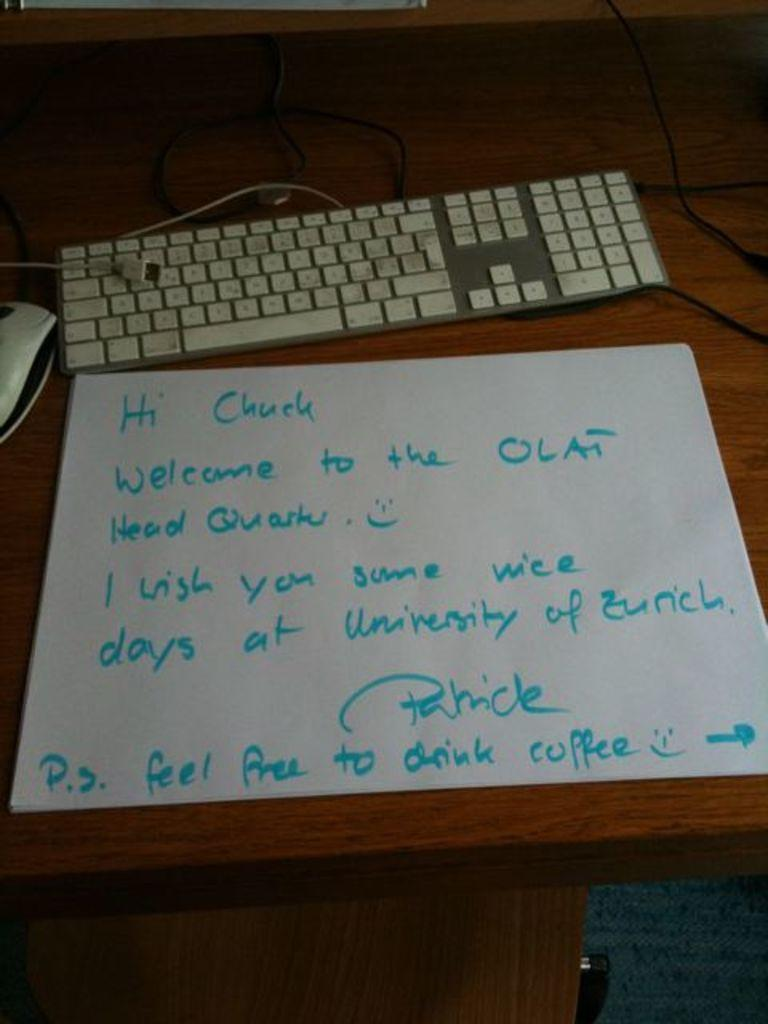<image>
Summarize the visual content of the image. A hand written note to  Chuck sits on a desk by the keyboard. 